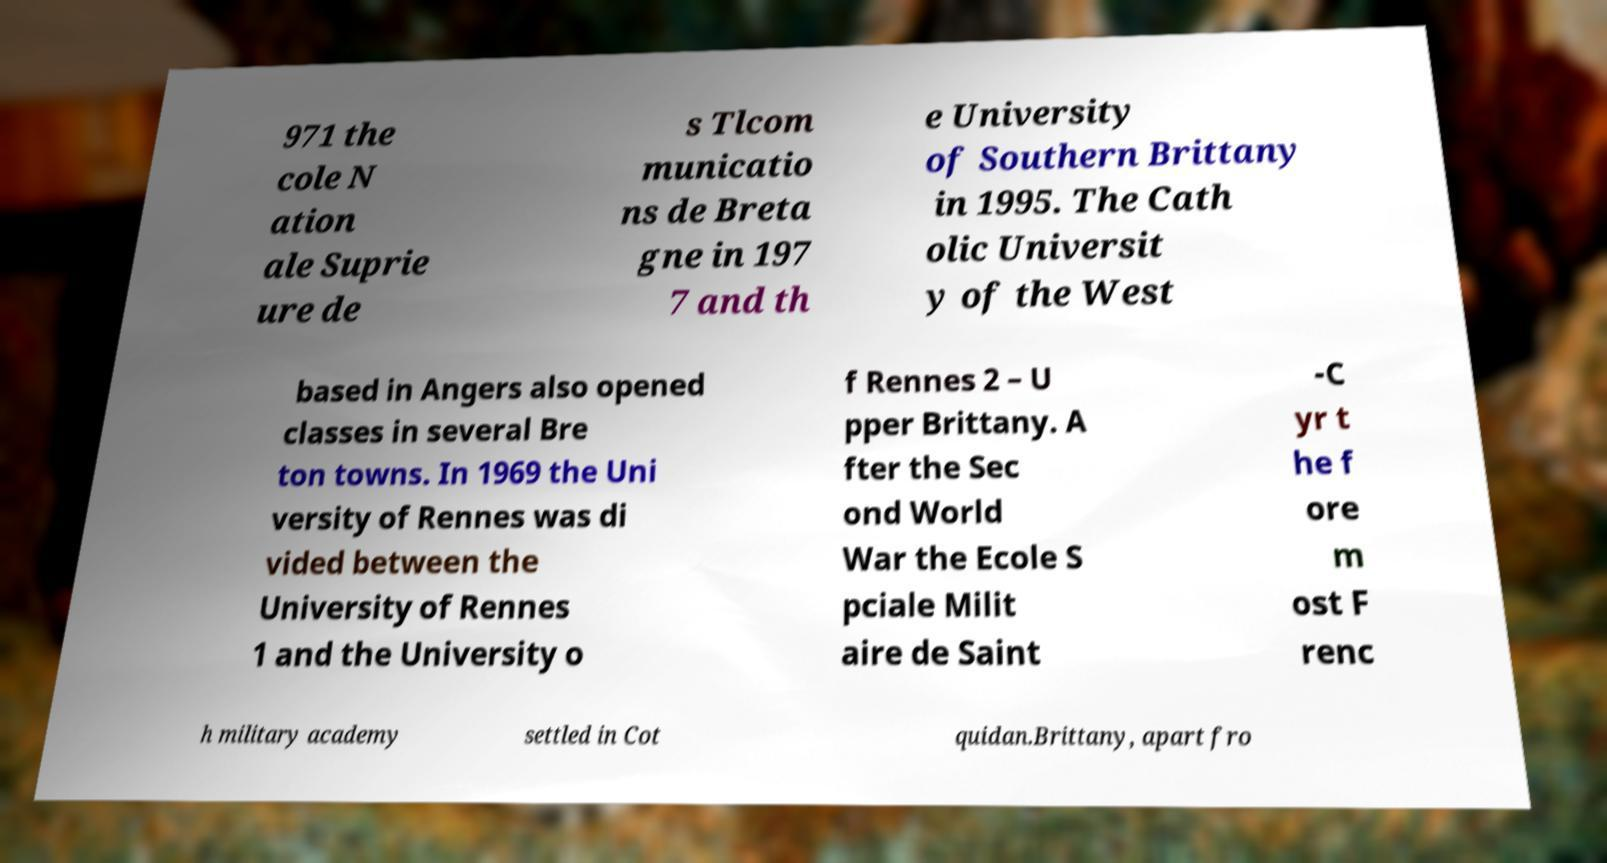Please identify and transcribe the text found in this image. 971 the cole N ation ale Suprie ure de s Tlcom municatio ns de Breta gne in 197 7 and th e University of Southern Brittany in 1995. The Cath olic Universit y of the West based in Angers also opened classes in several Bre ton towns. In 1969 the Uni versity of Rennes was di vided between the University of Rennes 1 and the University o f Rennes 2 – U pper Brittany. A fter the Sec ond World War the Ecole S pciale Milit aire de Saint -C yr t he f ore m ost F renc h military academy settled in Cot quidan.Brittany, apart fro 